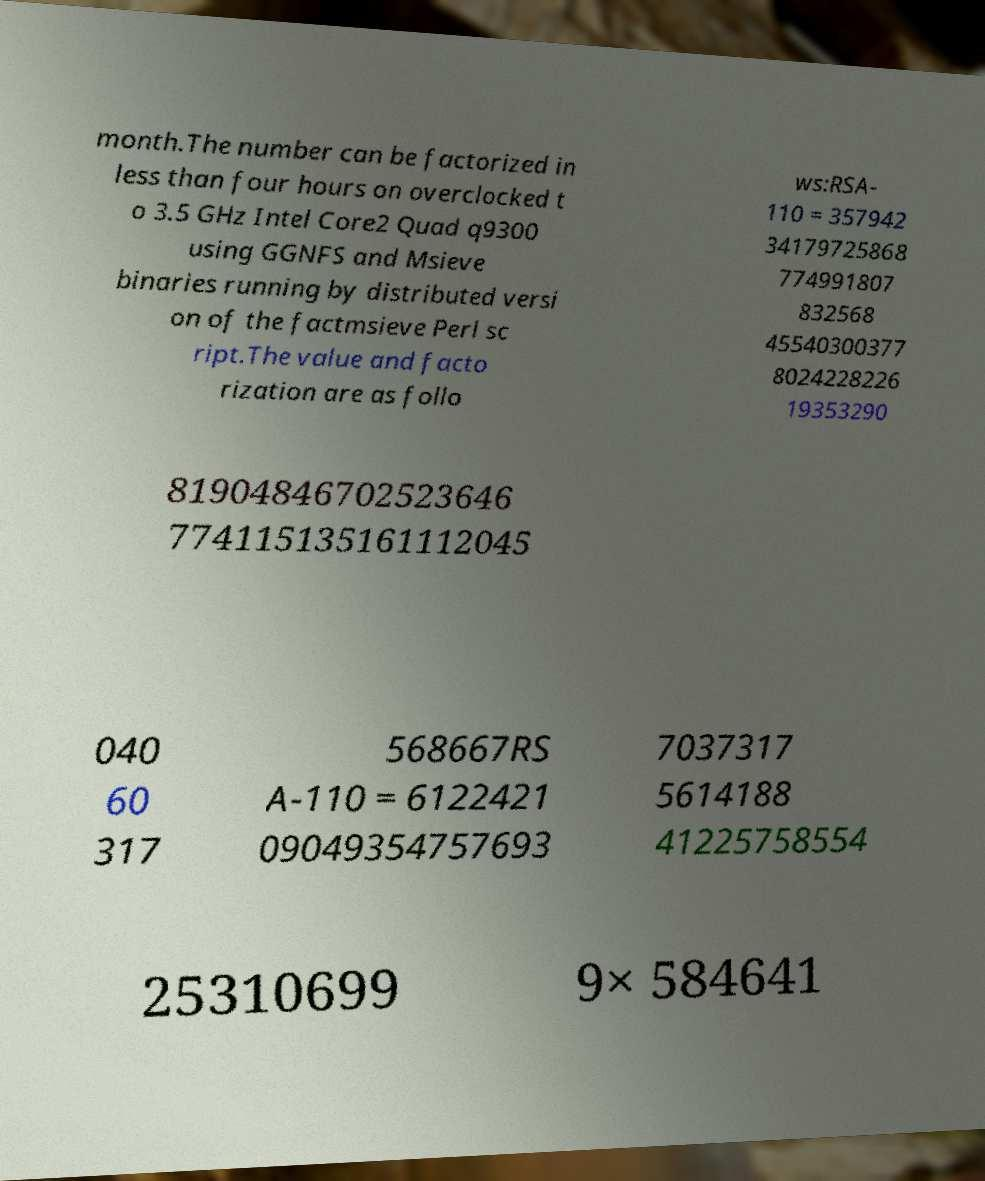Can you accurately transcribe the text from the provided image for me? month.The number can be factorized in less than four hours on overclocked t o 3.5 GHz Intel Core2 Quad q9300 using GGNFS and Msieve binaries running by distributed versi on of the factmsieve Perl sc ript.The value and facto rization are as follo ws:RSA- 110 = 357942 34179725868 774991807 832568 45540300377 8024228226 19353290 81904846702523646 774115135161112045 040 60 317 568667RS A-110 = 6122421 09049354757693 7037317 5614188 41225758554 25310699 9× 584641 